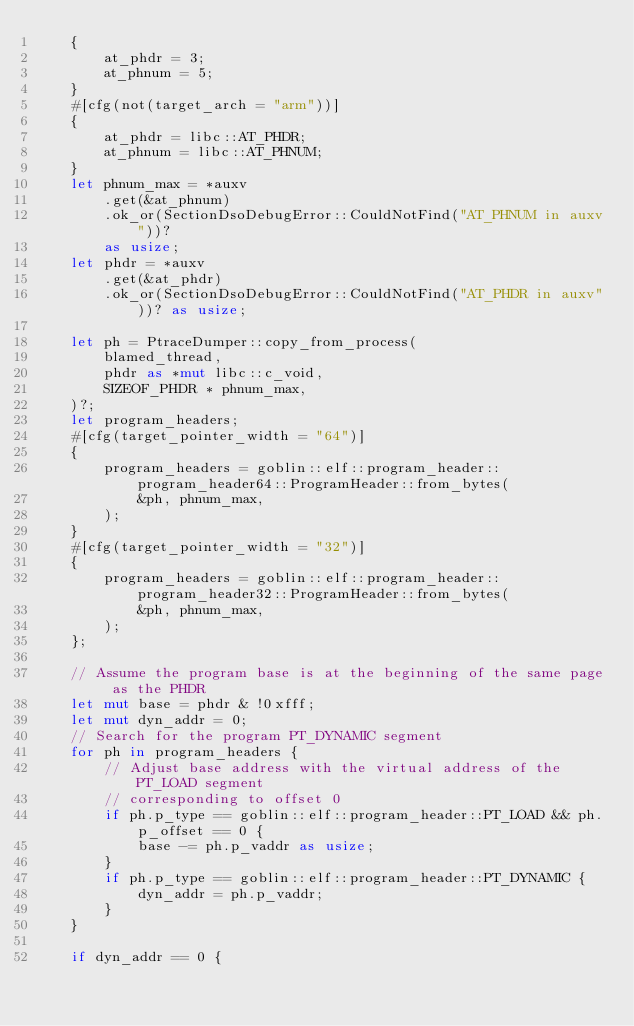<code> <loc_0><loc_0><loc_500><loc_500><_Rust_>    {
        at_phdr = 3;
        at_phnum = 5;
    }
    #[cfg(not(target_arch = "arm"))]
    {
        at_phdr = libc::AT_PHDR;
        at_phnum = libc::AT_PHNUM;
    }
    let phnum_max = *auxv
        .get(&at_phnum)
        .ok_or(SectionDsoDebugError::CouldNotFind("AT_PHNUM in auxv"))?
        as usize;
    let phdr = *auxv
        .get(&at_phdr)
        .ok_or(SectionDsoDebugError::CouldNotFind("AT_PHDR in auxv"))? as usize;

    let ph = PtraceDumper::copy_from_process(
        blamed_thread,
        phdr as *mut libc::c_void,
        SIZEOF_PHDR * phnum_max,
    )?;
    let program_headers;
    #[cfg(target_pointer_width = "64")]
    {
        program_headers = goblin::elf::program_header::program_header64::ProgramHeader::from_bytes(
            &ph, phnum_max,
        );
    }
    #[cfg(target_pointer_width = "32")]
    {
        program_headers = goblin::elf::program_header::program_header32::ProgramHeader::from_bytes(
            &ph, phnum_max,
        );
    };

    // Assume the program base is at the beginning of the same page as the PHDR
    let mut base = phdr & !0xfff;
    let mut dyn_addr = 0;
    // Search for the program PT_DYNAMIC segment
    for ph in program_headers {
        // Adjust base address with the virtual address of the PT_LOAD segment
        // corresponding to offset 0
        if ph.p_type == goblin::elf::program_header::PT_LOAD && ph.p_offset == 0 {
            base -= ph.p_vaddr as usize;
        }
        if ph.p_type == goblin::elf::program_header::PT_DYNAMIC {
            dyn_addr = ph.p_vaddr;
        }
    }

    if dyn_addr == 0 {</code> 